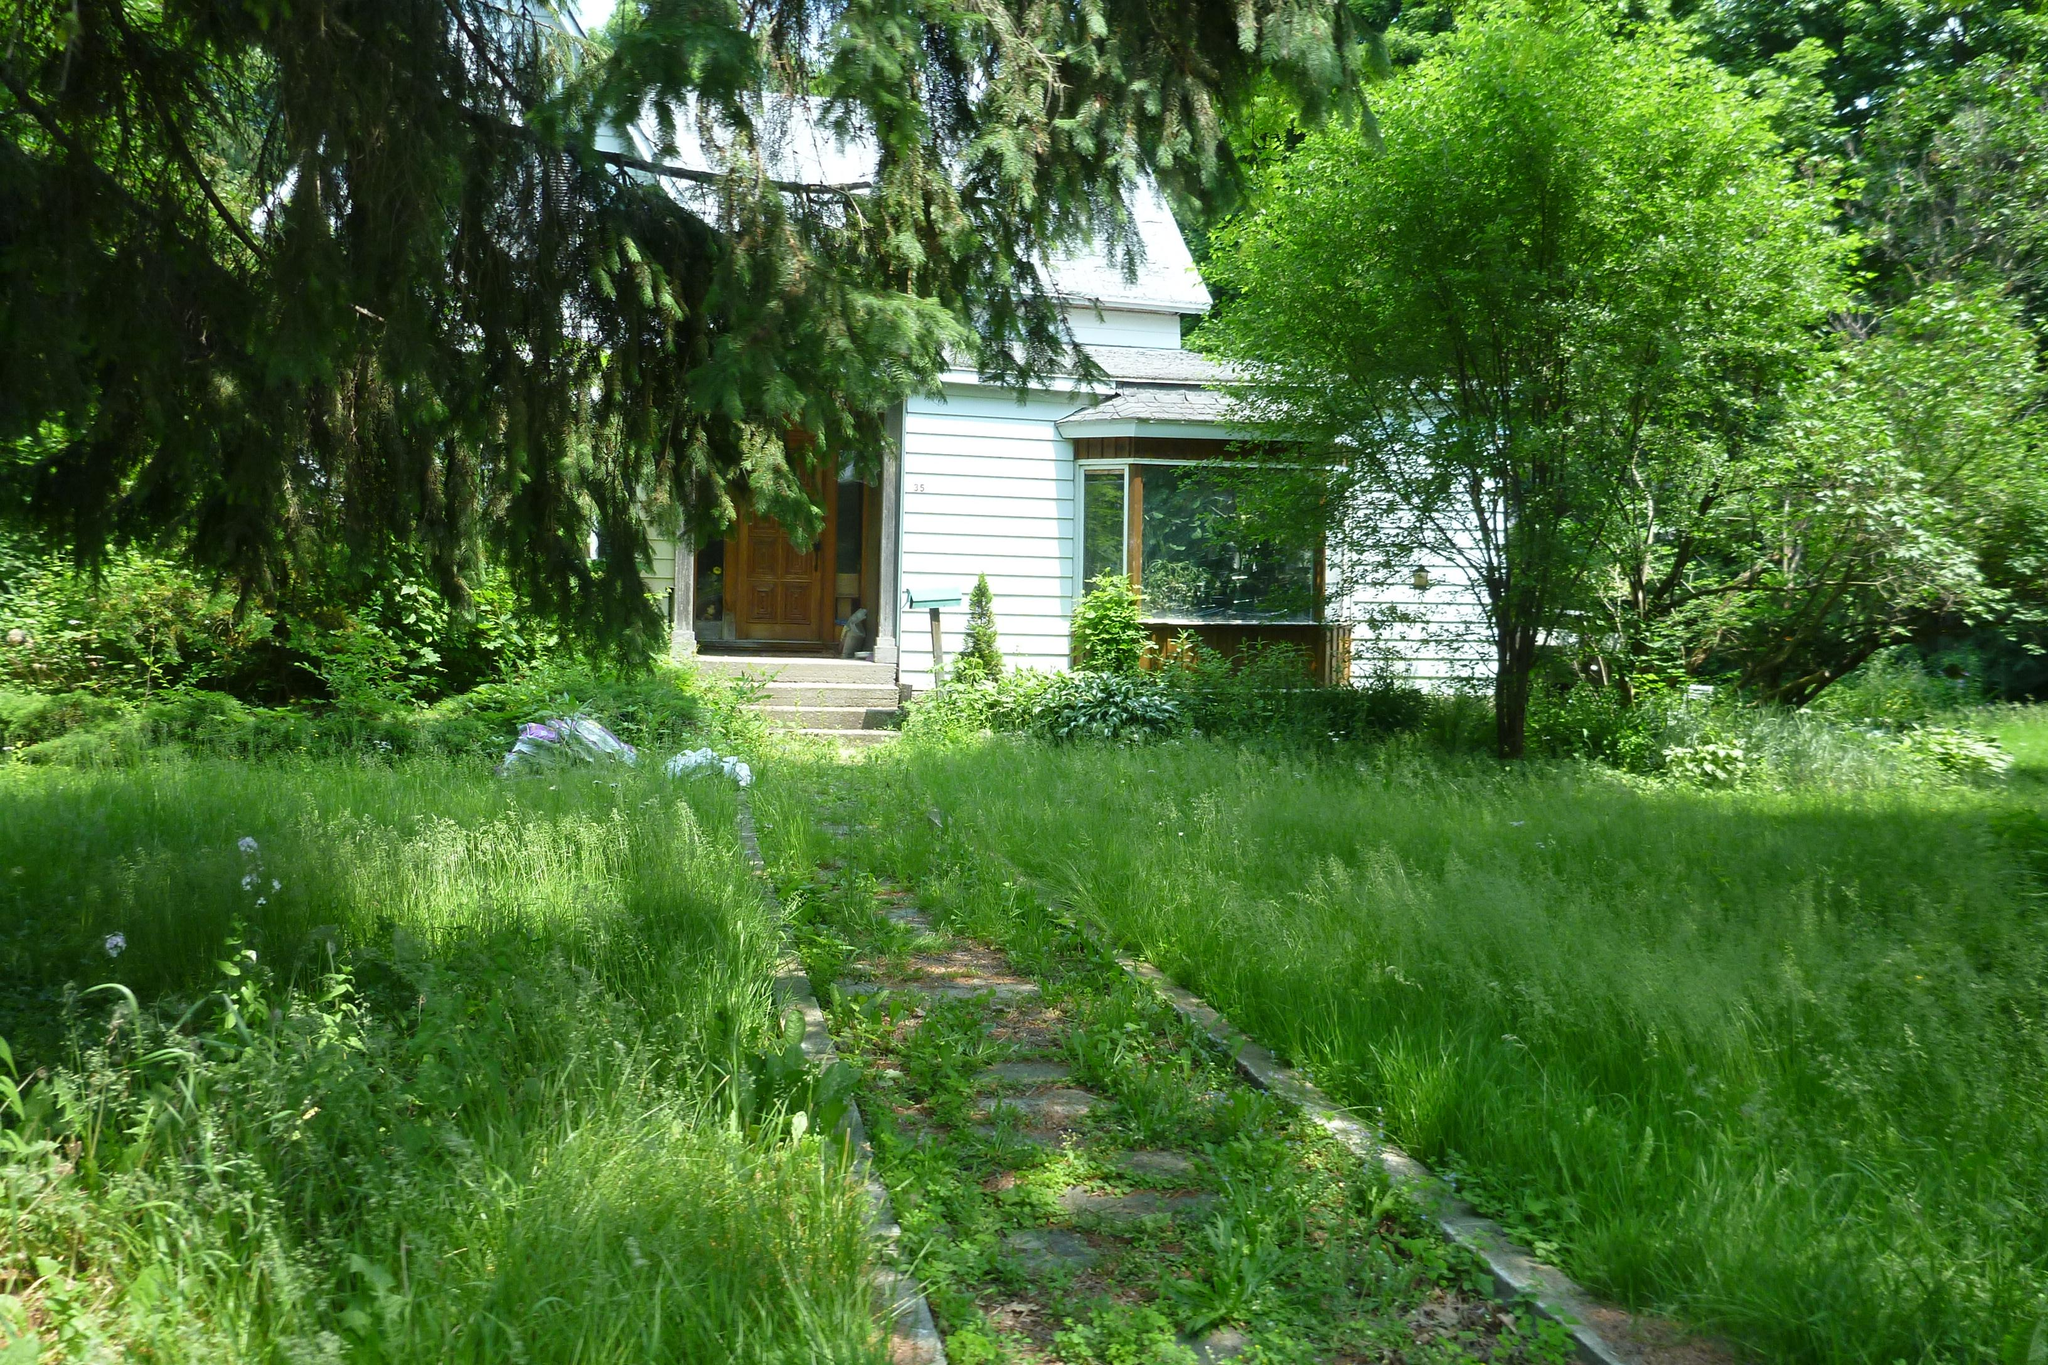What type of vegetation covers the land in the image? The land in the image is covered with grass. What other types of vegetation can be seen in the image? There are plants and trees visible in the image. What type of structure can be seen in the background of the image? There is a home visible in the background of the image. What type of cheese is being used to join the popcorn together in the image? There is no popcorn or cheese present in the image. How does the popcorn move around in the image? There is no popcorn present in the image, so it cannot move around. 